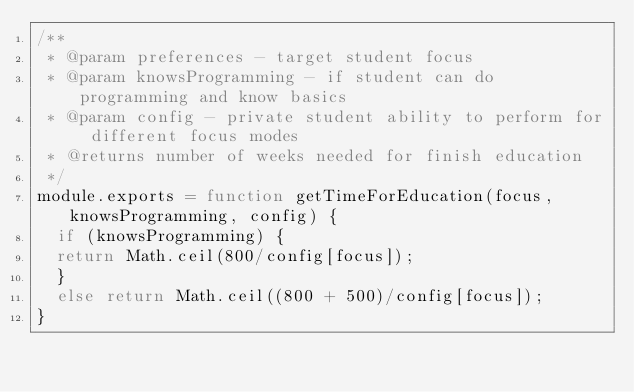Convert code to text. <code><loc_0><loc_0><loc_500><loc_500><_JavaScript_>/**
 * @param preferences - target student focus
 * @param knowsProgramming - if student can do programming and know basics
 * @param config - private student ability to perform for different focus modes
 * @returns number of weeks needed for finish education
 */
module.exports = function getTimeForEducation(focus, knowsProgramming, config) {
  if (knowsProgramming) {
  return Math.ceil(800/config[focus]);
  } 
  else return Math.ceil((800 + 500)/config[focus]);
}
  </code> 